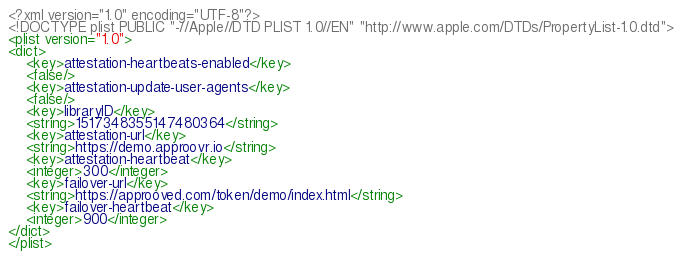Convert code to text. <code><loc_0><loc_0><loc_500><loc_500><_XML_><?xml version="1.0" encoding="UTF-8"?>
<!DOCTYPE plist PUBLIC "-//Apple//DTD PLIST 1.0//EN" "http://www.apple.com/DTDs/PropertyList-1.0.dtd">
<plist version="1.0">
<dict>
	<key>attestation-heartbeats-enabled</key>
	<false/>
	<key>attestation-update-user-agents</key>
	<false/>
	<key>libraryID</key>
	<string>1517348355147480364</string>
	<key>attestation-url</key>
	<string>https://demo.approovr.io</string>
	<key>attestation-heartbeat</key>
	<integer>300</integer>
	<key>failover-url</key>
	<string>https://approoved.com/token/demo/index.html</string>
	<key>failover-heartbeat</key>
	<integer>900</integer>
</dict>
</plist></code> 